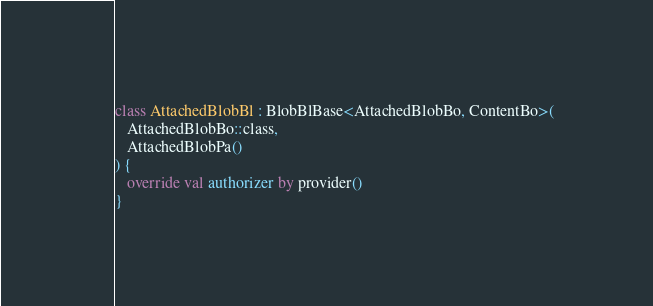Convert code to text. <code><loc_0><loc_0><loc_500><loc_500><_Kotlin_>
class AttachedBlobBl : BlobBlBase<AttachedBlobBo, ContentBo>(
   AttachedBlobBo::class,
   AttachedBlobPa()
) {
   override val authorizer by provider()
}
</code> 